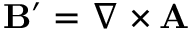Convert formula to latex. <formula><loc_0><loc_0><loc_500><loc_500>B ^ { \prime } = \nabla \times A</formula> 